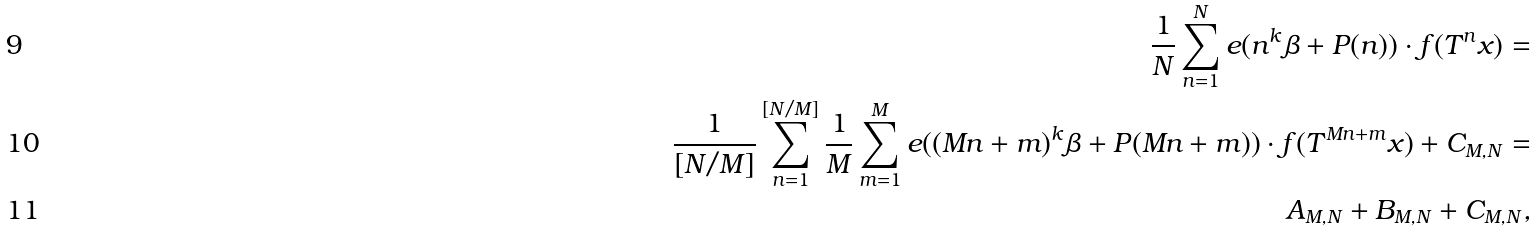<formula> <loc_0><loc_0><loc_500><loc_500>\frac { 1 } { N } \sum _ { n = 1 } ^ { N } e ( n ^ { k } \beta + P ( n ) ) \cdot f ( T ^ { n } x ) = \\ \frac { 1 } { [ N / M ] } \sum _ { n = 1 } ^ { [ N / M ] } \frac { 1 } { M } \sum _ { m = 1 } ^ { M } e ( ( M n + m ) ^ { k } \beta + P ( M n + m ) ) \cdot f ( T ^ { M n + m } x ) + C _ { M , N } = \\ A _ { M , N } + B _ { M , N } + C _ { M , N } ,</formula> 